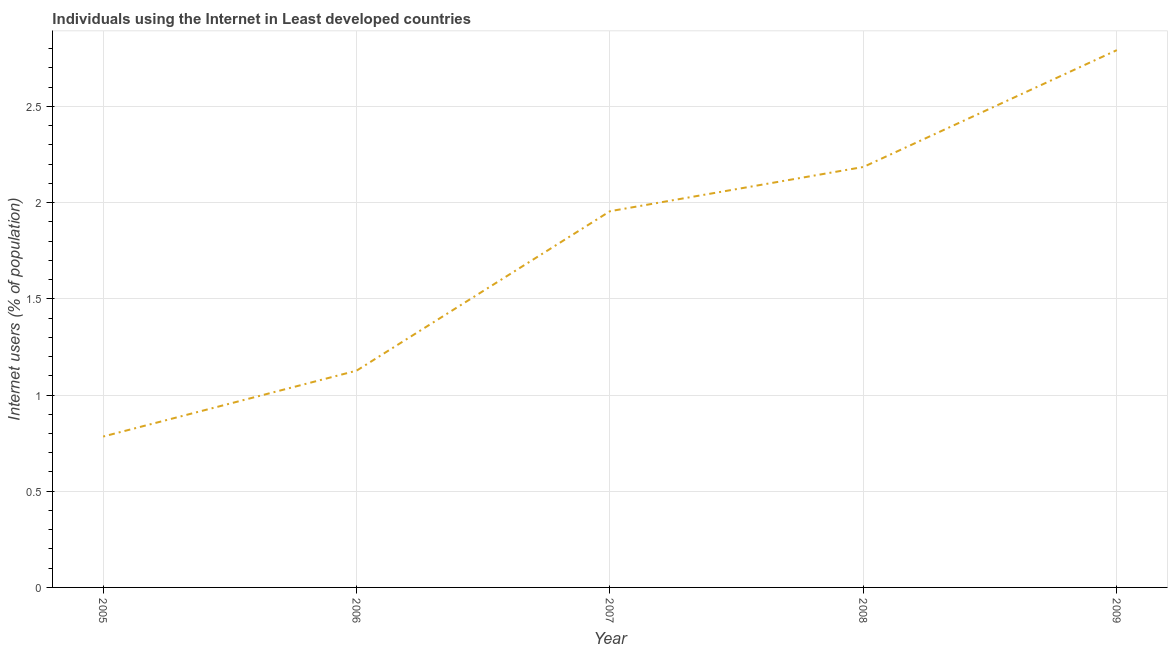What is the number of internet users in 2008?
Make the answer very short. 2.19. Across all years, what is the maximum number of internet users?
Your answer should be very brief. 2.79. Across all years, what is the minimum number of internet users?
Your answer should be very brief. 0.78. In which year was the number of internet users maximum?
Make the answer very short. 2009. In which year was the number of internet users minimum?
Your response must be concise. 2005. What is the sum of the number of internet users?
Keep it short and to the point. 8.84. What is the difference between the number of internet users in 2006 and 2008?
Provide a short and direct response. -1.06. What is the average number of internet users per year?
Ensure brevity in your answer.  1.77. What is the median number of internet users?
Your answer should be very brief. 1.96. In how many years, is the number of internet users greater than 2.7 %?
Your response must be concise. 1. What is the ratio of the number of internet users in 2005 to that in 2008?
Offer a very short reply. 0.36. Is the number of internet users in 2007 less than that in 2009?
Ensure brevity in your answer.  Yes. Is the difference between the number of internet users in 2006 and 2007 greater than the difference between any two years?
Your answer should be compact. No. What is the difference between the highest and the second highest number of internet users?
Keep it short and to the point. 0.61. What is the difference between the highest and the lowest number of internet users?
Ensure brevity in your answer.  2.01. In how many years, is the number of internet users greater than the average number of internet users taken over all years?
Provide a succinct answer. 3. How many years are there in the graph?
Ensure brevity in your answer.  5. What is the difference between two consecutive major ticks on the Y-axis?
Offer a very short reply. 0.5. Does the graph contain any zero values?
Keep it short and to the point. No. Does the graph contain grids?
Provide a succinct answer. Yes. What is the title of the graph?
Ensure brevity in your answer.  Individuals using the Internet in Least developed countries. What is the label or title of the X-axis?
Make the answer very short. Year. What is the label or title of the Y-axis?
Keep it short and to the point. Internet users (% of population). What is the Internet users (% of population) in 2005?
Give a very brief answer. 0.78. What is the Internet users (% of population) in 2006?
Your answer should be compact. 1.13. What is the Internet users (% of population) of 2007?
Provide a short and direct response. 1.96. What is the Internet users (% of population) in 2008?
Provide a short and direct response. 2.19. What is the Internet users (% of population) of 2009?
Provide a short and direct response. 2.79. What is the difference between the Internet users (% of population) in 2005 and 2006?
Provide a short and direct response. -0.34. What is the difference between the Internet users (% of population) in 2005 and 2007?
Your response must be concise. -1.17. What is the difference between the Internet users (% of population) in 2005 and 2008?
Your answer should be very brief. -1.4. What is the difference between the Internet users (% of population) in 2005 and 2009?
Offer a very short reply. -2.01. What is the difference between the Internet users (% of population) in 2006 and 2007?
Offer a terse response. -0.83. What is the difference between the Internet users (% of population) in 2006 and 2008?
Your response must be concise. -1.06. What is the difference between the Internet users (% of population) in 2006 and 2009?
Give a very brief answer. -1.67. What is the difference between the Internet users (% of population) in 2007 and 2008?
Your answer should be compact. -0.23. What is the difference between the Internet users (% of population) in 2007 and 2009?
Offer a very short reply. -0.84. What is the difference between the Internet users (% of population) in 2008 and 2009?
Provide a short and direct response. -0.61. What is the ratio of the Internet users (% of population) in 2005 to that in 2006?
Give a very brief answer. 0.7. What is the ratio of the Internet users (% of population) in 2005 to that in 2007?
Give a very brief answer. 0.4. What is the ratio of the Internet users (% of population) in 2005 to that in 2008?
Offer a terse response. 0.36. What is the ratio of the Internet users (% of population) in 2005 to that in 2009?
Provide a succinct answer. 0.28. What is the ratio of the Internet users (% of population) in 2006 to that in 2007?
Make the answer very short. 0.58. What is the ratio of the Internet users (% of population) in 2006 to that in 2008?
Your answer should be very brief. 0.52. What is the ratio of the Internet users (% of population) in 2006 to that in 2009?
Offer a terse response. 0.4. What is the ratio of the Internet users (% of population) in 2007 to that in 2008?
Your answer should be very brief. 0.9. What is the ratio of the Internet users (% of population) in 2008 to that in 2009?
Your answer should be very brief. 0.78. 